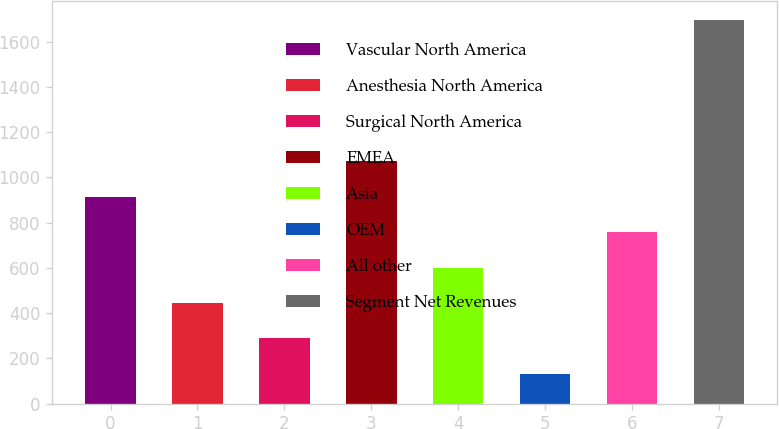<chart> <loc_0><loc_0><loc_500><loc_500><bar_chart><fcel>Vascular North America<fcel>Anesthesia North America<fcel>Surgical North America<fcel>EMEA<fcel>Asia<fcel>OEM<fcel>All other<fcel>Segment Net Revenues<nl><fcel>913.75<fcel>444.22<fcel>287.71<fcel>1070.26<fcel>600.73<fcel>131.2<fcel>757.24<fcel>1696.3<nl></chart> 